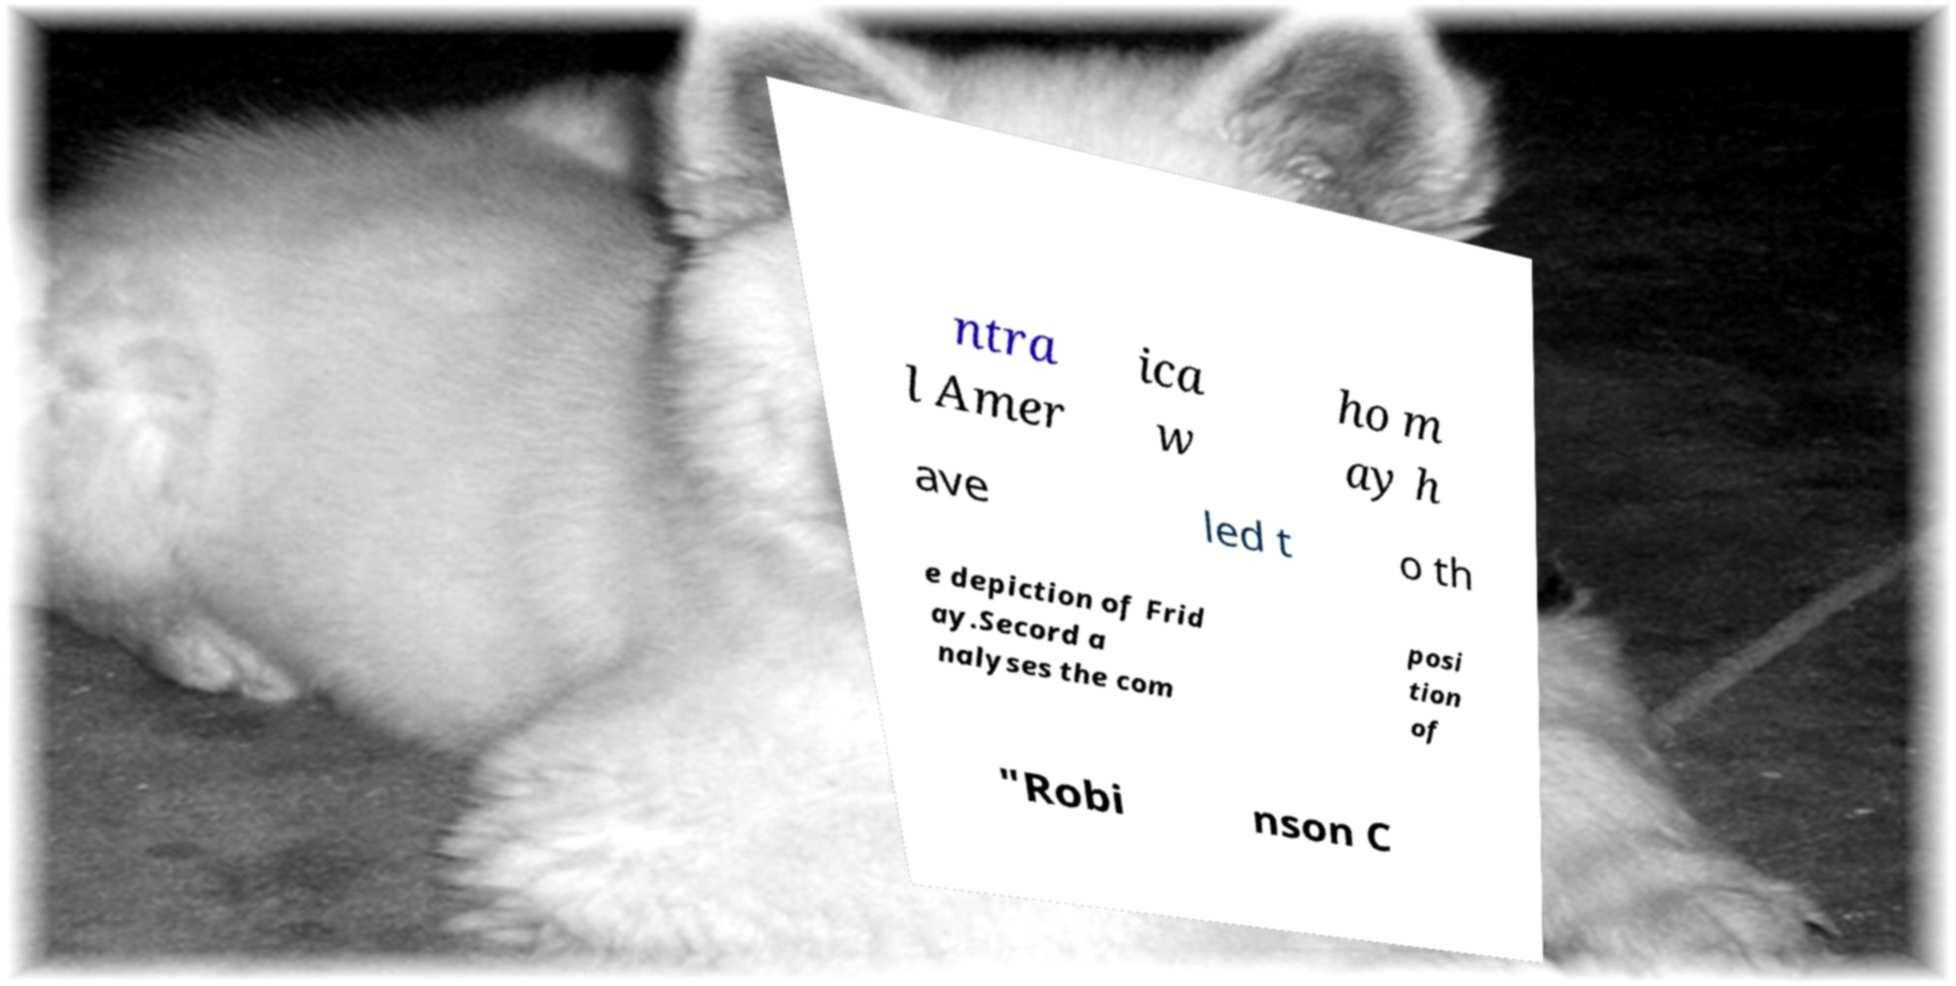Please identify and transcribe the text found in this image. ntra l Amer ica w ho m ay h ave led t o th e depiction of Frid ay.Secord a nalyses the com posi tion of "Robi nson C 